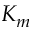<formula> <loc_0><loc_0><loc_500><loc_500>K _ { m }</formula> 